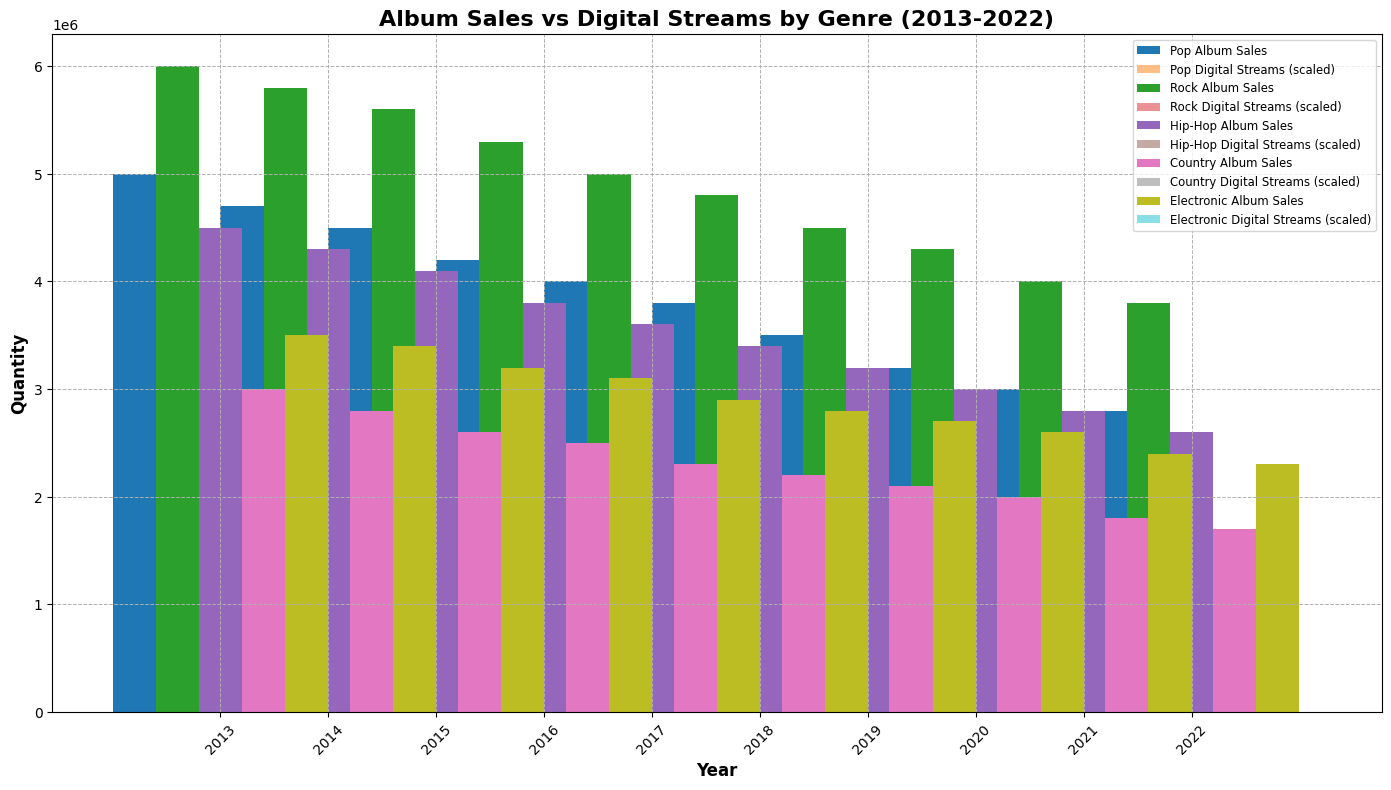What is the difference between Pop and Rock digital streams in 2022? To find the difference in digital streams between Pop and Rock in 2022, we compare the values: Pop has 6500000000 streams, and Rock has 4500000000 streams. The difference is 6500000000 - 4500000000.
Answer: 2000000000 Which genre had the highest album sales in 2013? By examining the heights of the bars representing album sales in 2013 across all genres, Rock had the highest album sales of 6000000.
Answer: Rock What is the average album sales for Hip-Hop over the decade? To find the average, sum the album sales for Hip-Hop from 2013 to 2022: (4500000 + 4300000 + 4100000 + 3800000 + 3600000 + 3400000 + 3200000 + 3000000 + 2800000 + 2600000) = 35300000, then divide by 10.
Answer: 3530000 How did Country album sales compare to Electronic album sales in 2016? Comparing the bar heights for album sales in 2016, Country had 2500000 and Electronic had 3100000. Electronic had higher sales.
Answer: Electronic had higher sales Are there any years where the album sales for Pop were higher than for Rock? By visually comparing the album sales bars for Pop and Rock across all years, there is no year where Pop sales are higher than Rock sales.
Answer: No What percentage increase did Hip-Hop digital streams experience from 2013 to 2015? Calculate the increase in Hip-Hop digital streams from 2013 to 2015: From 2500000000 to 3500000000, the increase is 1000000000. To find the percentage: (1000000000 / 2500000000) * 100 = 40%.
Answer: 40% How do the scaled digital streams of Country in 2020 compare visually to its album sales in the same year? The visual comparison shows that the height of the scaled digital streams bar for Country in 2020 matches up closely to the conventional album sales height for the same year, indicating the bars are comparable when scaled.
Answer: Comparable Which genre saw the smallest decline in album sales from 2013 to 2022? By assessing the decline in album sales from 2013 to 2022 for each genre, Rock's decline is from 6000000 to 3800000, which is 2200000, the smallest decline among all genres.
Answer: Rock What is the total digital streams for Pop and Hip-Hop combined in 2022? Sum the digital streams for Pop (6500000000) and Hip-Hop (7000000000) in 2022: 6500000000 + 7000000000.
Answer: 13500000000 Which genre had the lowest album sales in 2019? By inspecting the heights of the album sales bars for all genres in 2019, Country had the lowest album sales with 2100000.
Answer: Country 